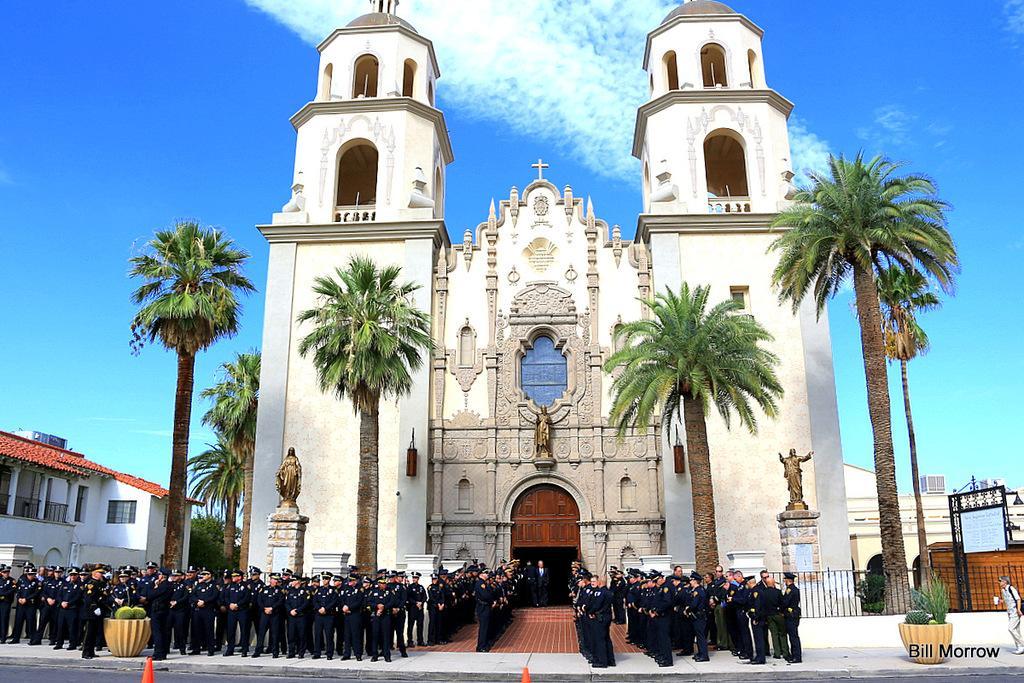In one or two sentences, can you explain what this image depicts? In the foreground I can see a group of people are standing on the road, house plants, trees, fence, boards, pillars, buildings, door, statues and windows. In the background I can see the blue sky. This image is taken may be during a day on the road. 